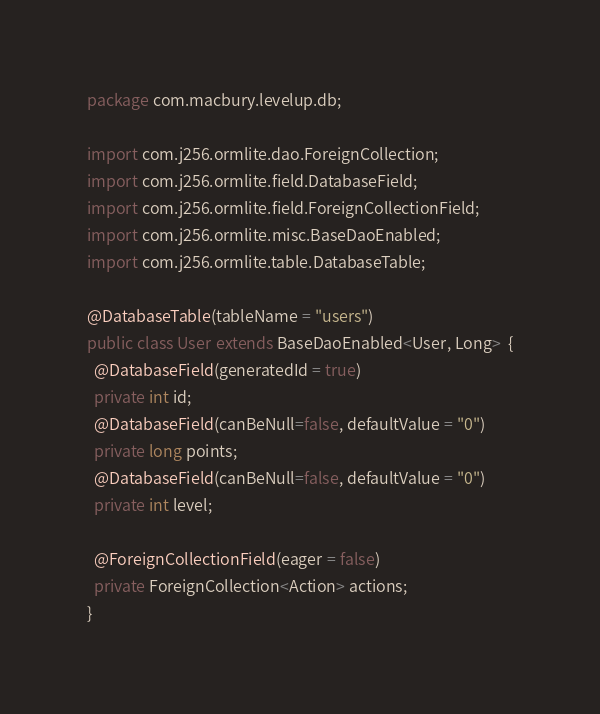<code> <loc_0><loc_0><loc_500><loc_500><_Java_>package com.macbury.levelup.db;

import com.j256.ormlite.dao.ForeignCollection;
import com.j256.ormlite.field.DatabaseField;
import com.j256.ormlite.field.ForeignCollectionField;
import com.j256.ormlite.misc.BaseDaoEnabled;
import com.j256.ormlite.table.DatabaseTable;

@DatabaseTable(tableName = "users")
public class User extends BaseDaoEnabled<User, Long>  {
  @DatabaseField(generatedId = true)
  private int id;
  @DatabaseField(canBeNull=false, defaultValue = "0")
  private long points;
  @DatabaseField(canBeNull=false, defaultValue = "0")
  private int level;
  
  @ForeignCollectionField(eager = false)
  private ForeignCollection<Action> actions;
}
</code> 